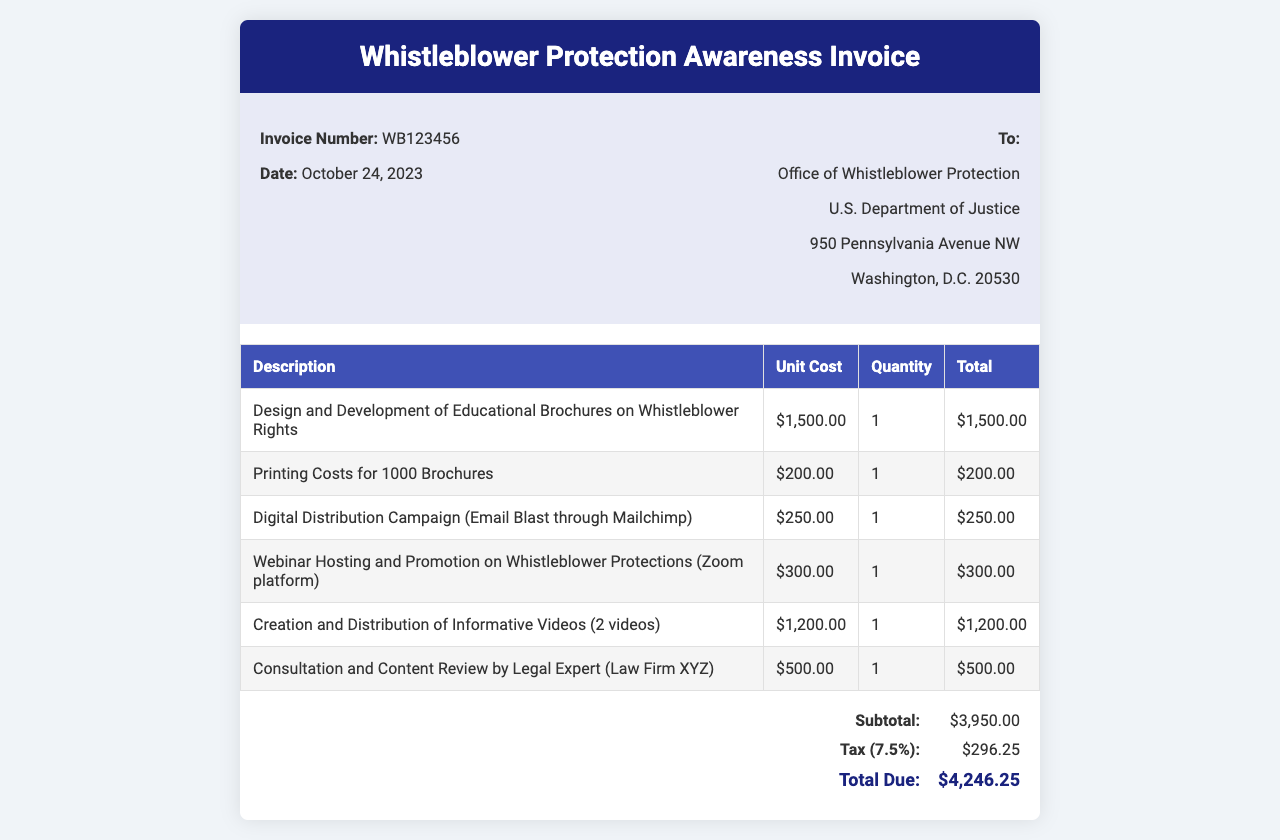What is the invoice number? The invoice number is specified in the document as part of the details section.
Answer: WB123456 What is the date of the invoice? The date of the invoice is provided in the details section of the document.
Answer: October 24, 2023 Who is the invoice addressed to? The recipient's name and organization are mentioned in the "To" section of the invoice.
Answer: Office of Whistleblower Protection What is the total due amount? The total due amount is computed as the sum of the subtotal and tax in the invoice summary.
Answer: $4,246.25 What percentage is the tax applied to the subtotal? The tax rate is indicated in the summary section of the invoice.
Answer: 7.5% What is the unit cost for printing costs for 1000 brochures? The unit cost for printing is specified in the table detailing the services.
Answer: $200.00 How many informative videos were created and distributed? The quantity of videos is mentioned explicitly in the description of the related service.
Answer: 2 videos What type of platform was used for hosting the webinar? The specific platform for the webinar is stated in the description of the related cost.
Answer: Zoom What is included in the consultation and content review service? The service provider is identified within the invoice detailing the consultation cost.
Answer: Law Firm XYZ 